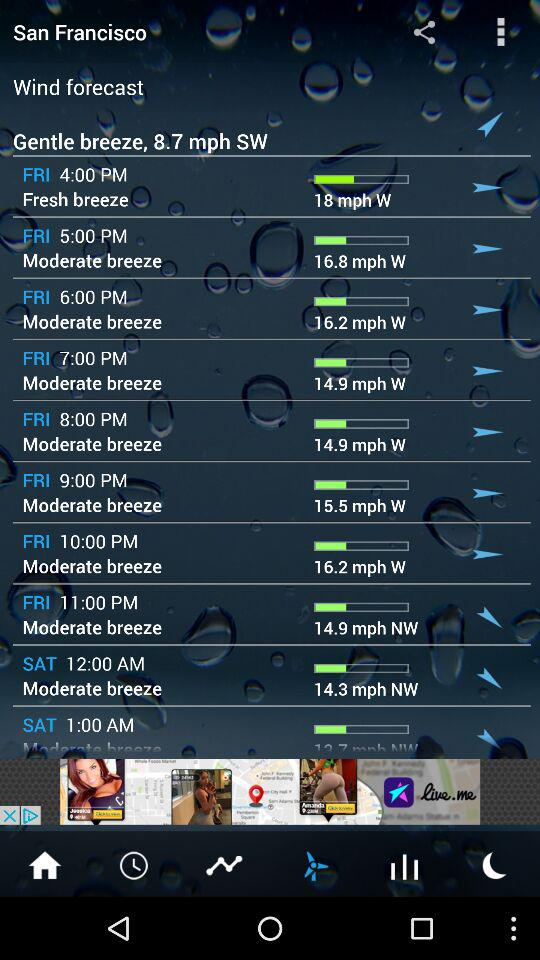What is the wind speed on Friday at 5 PM? The wind speed is 16.8 mph. 